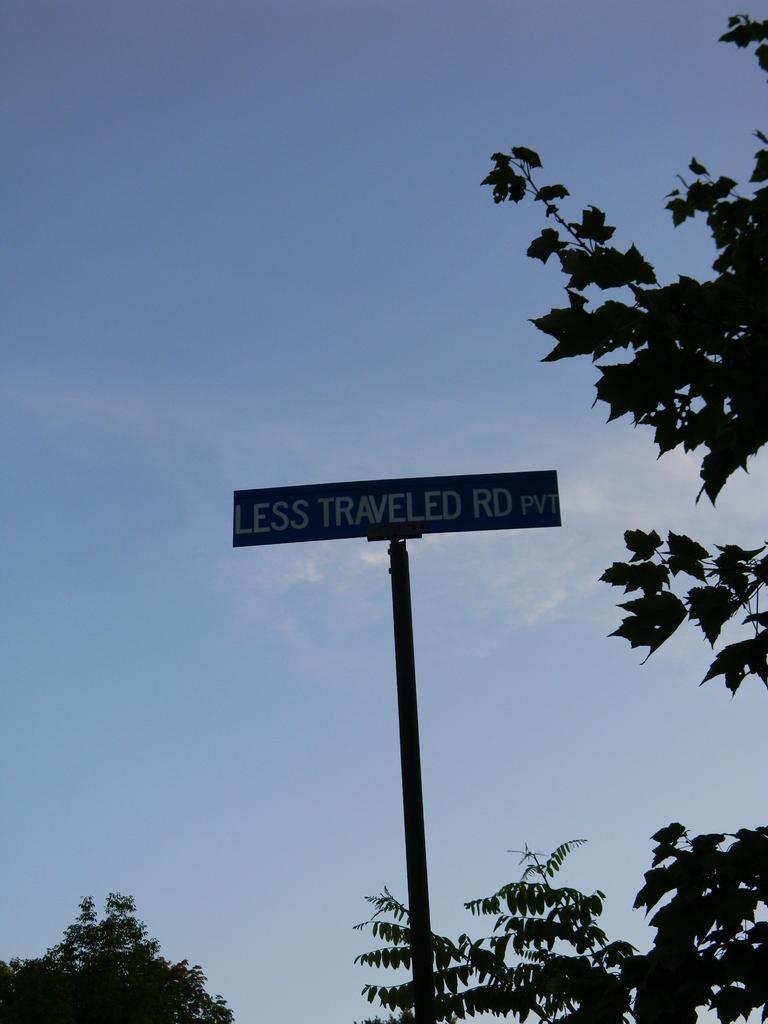Please provide a concise description of this image. Here there are trees on the left and right side and in the middle there is a name board pole. In the background there are clouds in the sky. 